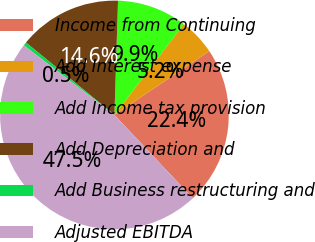<chart> <loc_0><loc_0><loc_500><loc_500><pie_chart><fcel>Income from Continuing<fcel>Add Interest expense<fcel>Add Income tax provision<fcel>Add Depreciation and<fcel>Add Business restructuring and<fcel>Adjusted EBITDA<nl><fcel>22.41%<fcel>5.19%<fcel>9.88%<fcel>14.58%<fcel>0.49%<fcel>47.45%<nl></chart> 